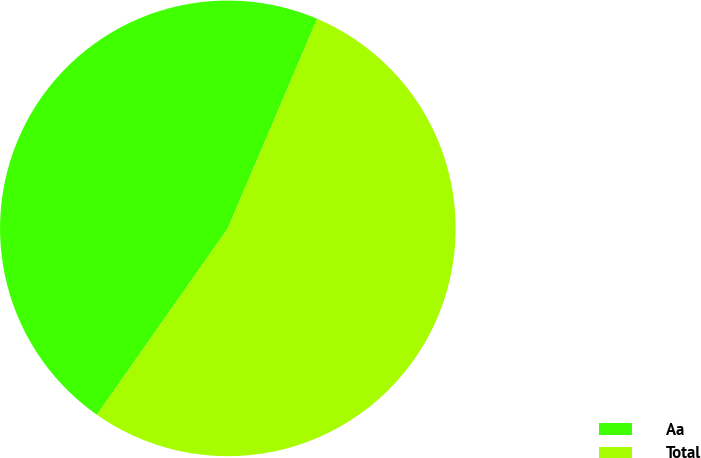Convert chart. <chart><loc_0><loc_0><loc_500><loc_500><pie_chart><fcel>Aa<fcel>Total<nl><fcel>46.67%<fcel>53.33%<nl></chart> 